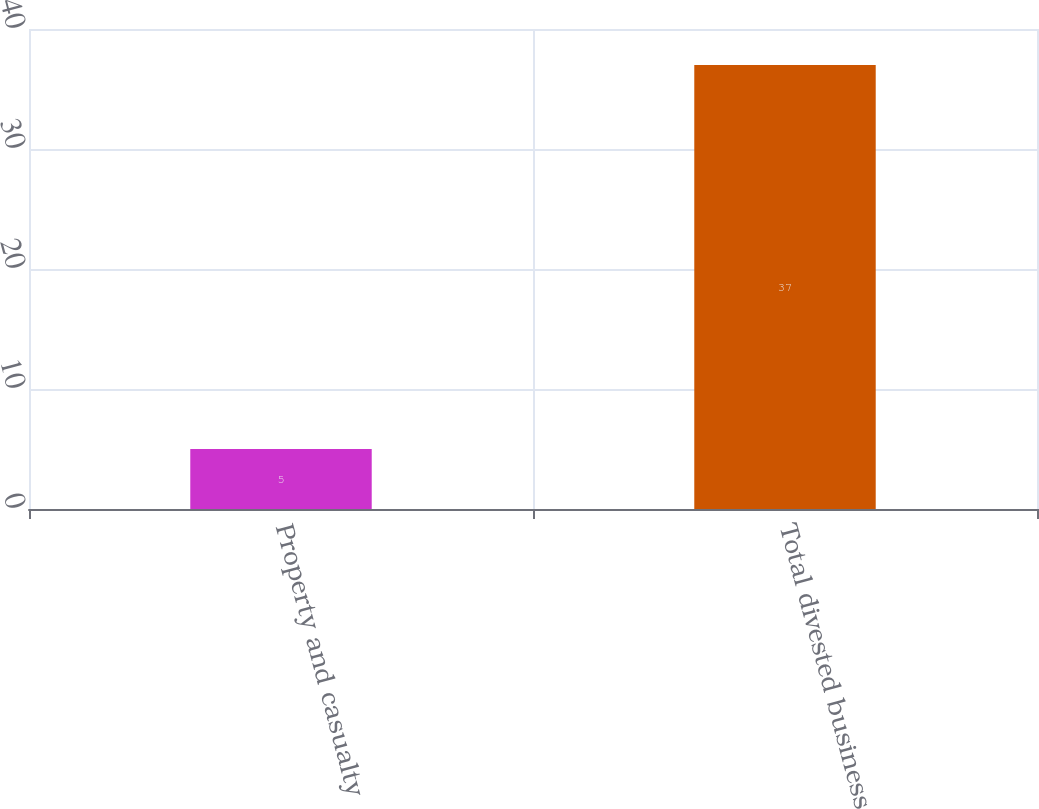Convert chart to OTSL. <chart><loc_0><loc_0><loc_500><loc_500><bar_chart><fcel>Property and casualty<fcel>Total divested business<nl><fcel>5<fcel>37<nl></chart> 